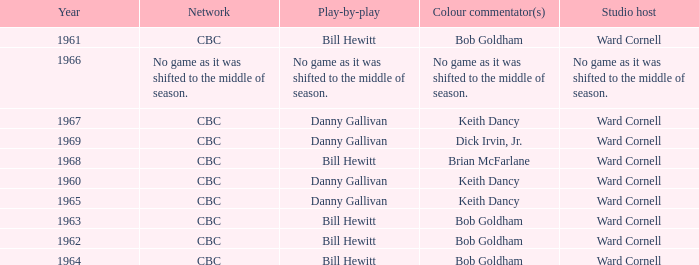Who did the play-by-play with studio host Ward Cornell and color commentator Bob Goldham? Bill Hewitt, Bill Hewitt, Bill Hewitt, Bill Hewitt. 